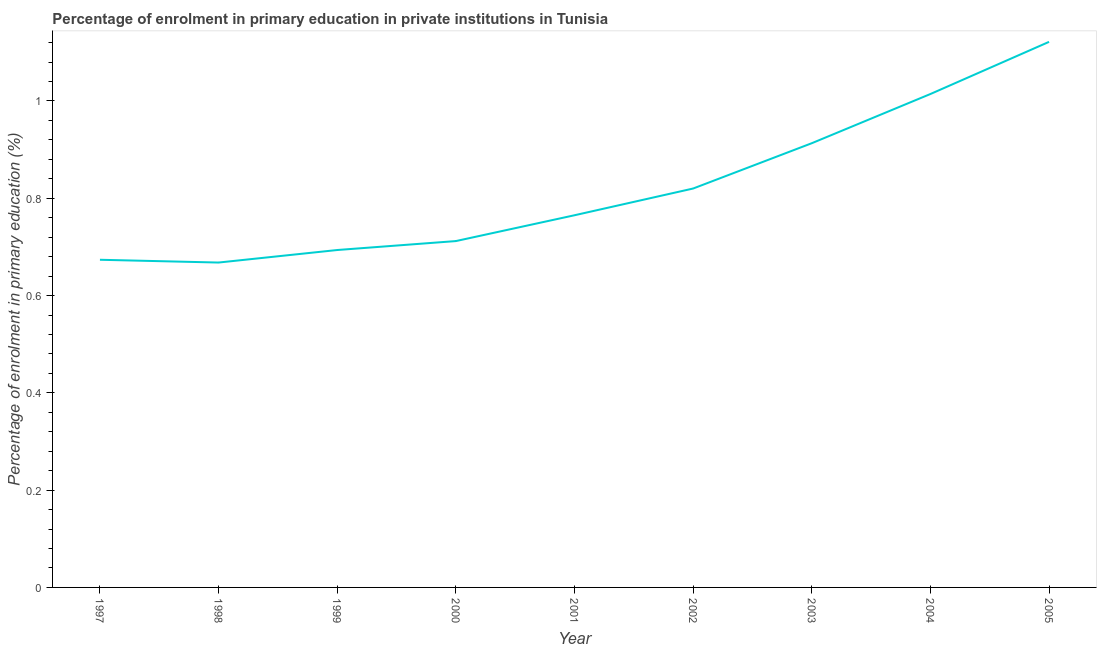What is the enrolment percentage in primary education in 2003?
Ensure brevity in your answer.  0.91. Across all years, what is the maximum enrolment percentage in primary education?
Provide a succinct answer. 1.12. Across all years, what is the minimum enrolment percentage in primary education?
Your response must be concise. 0.67. In which year was the enrolment percentage in primary education minimum?
Keep it short and to the point. 1998. What is the sum of the enrolment percentage in primary education?
Provide a short and direct response. 7.38. What is the difference between the enrolment percentage in primary education in 1997 and 2005?
Provide a succinct answer. -0.45. What is the average enrolment percentage in primary education per year?
Keep it short and to the point. 0.82. What is the median enrolment percentage in primary education?
Ensure brevity in your answer.  0.77. What is the ratio of the enrolment percentage in primary education in 2001 to that in 2002?
Your answer should be very brief. 0.93. What is the difference between the highest and the second highest enrolment percentage in primary education?
Your response must be concise. 0.11. Is the sum of the enrolment percentage in primary education in 1999 and 2004 greater than the maximum enrolment percentage in primary education across all years?
Make the answer very short. Yes. What is the difference between the highest and the lowest enrolment percentage in primary education?
Your answer should be very brief. 0.45. Does the enrolment percentage in primary education monotonically increase over the years?
Provide a short and direct response. No. Are the values on the major ticks of Y-axis written in scientific E-notation?
Ensure brevity in your answer.  No. Does the graph contain any zero values?
Ensure brevity in your answer.  No. What is the title of the graph?
Give a very brief answer. Percentage of enrolment in primary education in private institutions in Tunisia. What is the label or title of the Y-axis?
Give a very brief answer. Percentage of enrolment in primary education (%). What is the Percentage of enrolment in primary education (%) of 1997?
Provide a short and direct response. 0.67. What is the Percentage of enrolment in primary education (%) in 1998?
Your answer should be compact. 0.67. What is the Percentage of enrolment in primary education (%) in 1999?
Ensure brevity in your answer.  0.69. What is the Percentage of enrolment in primary education (%) of 2000?
Give a very brief answer. 0.71. What is the Percentage of enrolment in primary education (%) in 2001?
Keep it short and to the point. 0.77. What is the Percentage of enrolment in primary education (%) in 2002?
Provide a short and direct response. 0.82. What is the Percentage of enrolment in primary education (%) of 2003?
Your answer should be very brief. 0.91. What is the Percentage of enrolment in primary education (%) in 2004?
Ensure brevity in your answer.  1.01. What is the Percentage of enrolment in primary education (%) in 2005?
Make the answer very short. 1.12. What is the difference between the Percentage of enrolment in primary education (%) in 1997 and 1998?
Your answer should be very brief. 0.01. What is the difference between the Percentage of enrolment in primary education (%) in 1997 and 1999?
Offer a terse response. -0.02. What is the difference between the Percentage of enrolment in primary education (%) in 1997 and 2000?
Your response must be concise. -0.04. What is the difference between the Percentage of enrolment in primary education (%) in 1997 and 2001?
Your answer should be compact. -0.09. What is the difference between the Percentage of enrolment in primary education (%) in 1997 and 2002?
Offer a terse response. -0.15. What is the difference between the Percentage of enrolment in primary education (%) in 1997 and 2003?
Offer a very short reply. -0.24. What is the difference between the Percentage of enrolment in primary education (%) in 1997 and 2004?
Your answer should be very brief. -0.34. What is the difference between the Percentage of enrolment in primary education (%) in 1997 and 2005?
Make the answer very short. -0.45. What is the difference between the Percentage of enrolment in primary education (%) in 1998 and 1999?
Offer a very short reply. -0.03. What is the difference between the Percentage of enrolment in primary education (%) in 1998 and 2000?
Make the answer very short. -0.04. What is the difference between the Percentage of enrolment in primary education (%) in 1998 and 2001?
Make the answer very short. -0.1. What is the difference between the Percentage of enrolment in primary education (%) in 1998 and 2002?
Provide a succinct answer. -0.15. What is the difference between the Percentage of enrolment in primary education (%) in 1998 and 2003?
Your answer should be very brief. -0.25. What is the difference between the Percentage of enrolment in primary education (%) in 1998 and 2004?
Give a very brief answer. -0.35. What is the difference between the Percentage of enrolment in primary education (%) in 1998 and 2005?
Your answer should be very brief. -0.45. What is the difference between the Percentage of enrolment in primary education (%) in 1999 and 2000?
Make the answer very short. -0.02. What is the difference between the Percentage of enrolment in primary education (%) in 1999 and 2001?
Provide a short and direct response. -0.07. What is the difference between the Percentage of enrolment in primary education (%) in 1999 and 2002?
Keep it short and to the point. -0.13. What is the difference between the Percentage of enrolment in primary education (%) in 1999 and 2003?
Offer a very short reply. -0.22. What is the difference between the Percentage of enrolment in primary education (%) in 1999 and 2004?
Keep it short and to the point. -0.32. What is the difference between the Percentage of enrolment in primary education (%) in 1999 and 2005?
Offer a very short reply. -0.43. What is the difference between the Percentage of enrolment in primary education (%) in 2000 and 2001?
Your answer should be compact. -0.05. What is the difference between the Percentage of enrolment in primary education (%) in 2000 and 2002?
Your answer should be compact. -0.11. What is the difference between the Percentage of enrolment in primary education (%) in 2000 and 2003?
Make the answer very short. -0.2. What is the difference between the Percentage of enrolment in primary education (%) in 2000 and 2004?
Provide a short and direct response. -0.3. What is the difference between the Percentage of enrolment in primary education (%) in 2000 and 2005?
Provide a succinct answer. -0.41. What is the difference between the Percentage of enrolment in primary education (%) in 2001 and 2002?
Ensure brevity in your answer.  -0.05. What is the difference between the Percentage of enrolment in primary education (%) in 2001 and 2003?
Keep it short and to the point. -0.15. What is the difference between the Percentage of enrolment in primary education (%) in 2001 and 2004?
Ensure brevity in your answer.  -0.25. What is the difference between the Percentage of enrolment in primary education (%) in 2001 and 2005?
Ensure brevity in your answer.  -0.36. What is the difference between the Percentage of enrolment in primary education (%) in 2002 and 2003?
Offer a very short reply. -0.09. What is the difference between the Percentage of enrolment in primary education (%) in 2002 and 2004?
Give a very brief answer. -0.19. What is the difference between the Percentage of enrolment in primary education (%) in 2002 and 2005?
Provide a short and direct response. -0.3. What is the difference between the Percentage of enrolment in primary education (%) in 2003 and 2004?
Make the answer very short. -0.1. What is the difference between the Percentage of enrolment in primary education (%) in 2003 and 2005?
Make the answer very short. -0.21. What is the difference between the Percentage of enrolment in primary education (%) in 2004 and 2005?
Make the answer very short. -0.11. What is the ratio of the Percentage of enrolment in primary education (%) in 1997 to that in 1998?
Your answer should be compact. 1.01. What is the ratio of the Percentage of enrolment in primary education (%) in 1997 to that in 1999?
Your answer should be compact. 0.97. What is the ratio of the Percentage of enrolment in primary education (%) in 1997 to that in 2000?
Keep it short and to the point. 0.95. What is the ratio of the Percentage of enrolment in primary education (%) in 1997 to that in 2002?
Offer a terse response. 0.82. What is the ratio of the Percentage of enrolment in primary education (%) in 1997 to that in 2003?
Give a very brief answer. 0.74. What is the ratio of the Percentage of enrolment in primary education (%) in 1997 to that in 2004?
Make the answer very short. 0.66. What is the ratio of the Percentage of enrolment in primary education (%) in 1997 to that in 2005?
Provide a succinct answer. 0.6. What is the ratio of the Percentage of enrolment in primary education (%) in 1998 to that in 1999?
Ensure brevity in your answer.  0.96. What is the ratio of the Percentage of enrolment in primary education (%) in 1998 to that in 2000?
Offer a very short reply. 0.94. What is the ratio of the Percentage of enrolment in primary education (%) in 1998 to that in 2001?
Keep it short and to the point. 0.87. What is the ratio of the Percentage of enrolment in primary education (%) in 1998 to that in 2002?
Offer a terse response. 0.81. What is the ratio of the Percentage of enrolment in primary education (%) in 1998 to that in 2003?
Ensure brevity in your answer.  0.73. What is the ratio of the Percentage of enrolment in primary education (%) in 1998 to that in 2004?
Ensure brevity in your answer.  0.66. What is the ratio of the Percentage of enrolment in primary education (%) in 1998 to that in 2005?
Your response must be concise. 0.6. What is the ratio of the Percentage of enrolment in primary education (%) in 1999 to that in 2000?
Provide a succinct answer. 0.97. What is the ratio of the Percentage of enrolment in primary education (%) in 1999 to that in 2001?
Your answer should be compact. 0.91. What is the ratio of the Percentage of enrolment in primary education (%) in 1999 to that in 2002?
Offer a very short reply. 0.85. What is the ratio of the Percentage of enrolment in primary education (%) in 1999 to that in 2003?
Offer a very short reply. 0.76. What is the ratio of the Percentage of enrolment in primary education (%) in 1999 to that in 2004?
Your answer should be compact. 0.68. What is the ratio of the Percentage of enrolment in primary education (%) in 1999 to that in 2005?
Offer a terse response. 0.62. What is the ratio of the Percentage of enrolment in primary education (%) in 2000 to that in 2001?
Offer a very short reply. 0.93. What is the ratio of the Percentage of enrolment in primary education (%) in 2000 to that in 2002?
Your answer should be compact. 0.87. What is the ratio of the Percentage of enrolment in primary education (%) in 2000 to that in 2003?
Your response must be concise. 0.78. What is the ratio of the Percentage of enrolment in primary education (%) in 2000 to that in 2004?
Provide a succinct answer. 0.7. What is the ratio of the Percentage of enrolment in primary education (%) in 2000 to that in 2005?
Give a very brief answer. 0.64. What is the ratio of the Percentage of enrolment in primary education (%) in 2001 to that in 2002?
Provide a short and direct response. 0.93. What is the ratio of the Percentage of enrolment in primary education (%) in 2001 to that in 2003?
Your answer should be very brief. 0.84. What is the ratio of the Percentage of enrolment in primary education (%) in 2001 to that in 2004?
Offer a very short reply. 0.75. What is the ratio of the Percentage of enrolment in primary education (%) in 2001 to that in 2005?
Offer a terse response. 0.68. What is the ratio of the Percentage of enrolment in primary education (%) in 2002 to that in 2003?
Make the answer very short. 0.9. What is the ratio of the Percentage of enrolment in primary education (%) in 2002 to that in 2004?
Your response must be concise. 0.81. What is the ratio of the Percentage of enrolment in primary education (%) in 2002 to that in 2005?
Your response must be concise. 0.73. What is the ratio of the Percentage of enrolment in primary education (%) in 2003 to that in 2004?
Offer a very short reply. 0.9. What is the ratio of the Percentage of enrolment in primary education (%) in 2003 to that in 2005?
Offer a terse response. 0.81. What is the ratio of the Percentage of enrolment in primary education (%) in 2004 to that in 2005?
Keep it short and to the point. 0.9. 